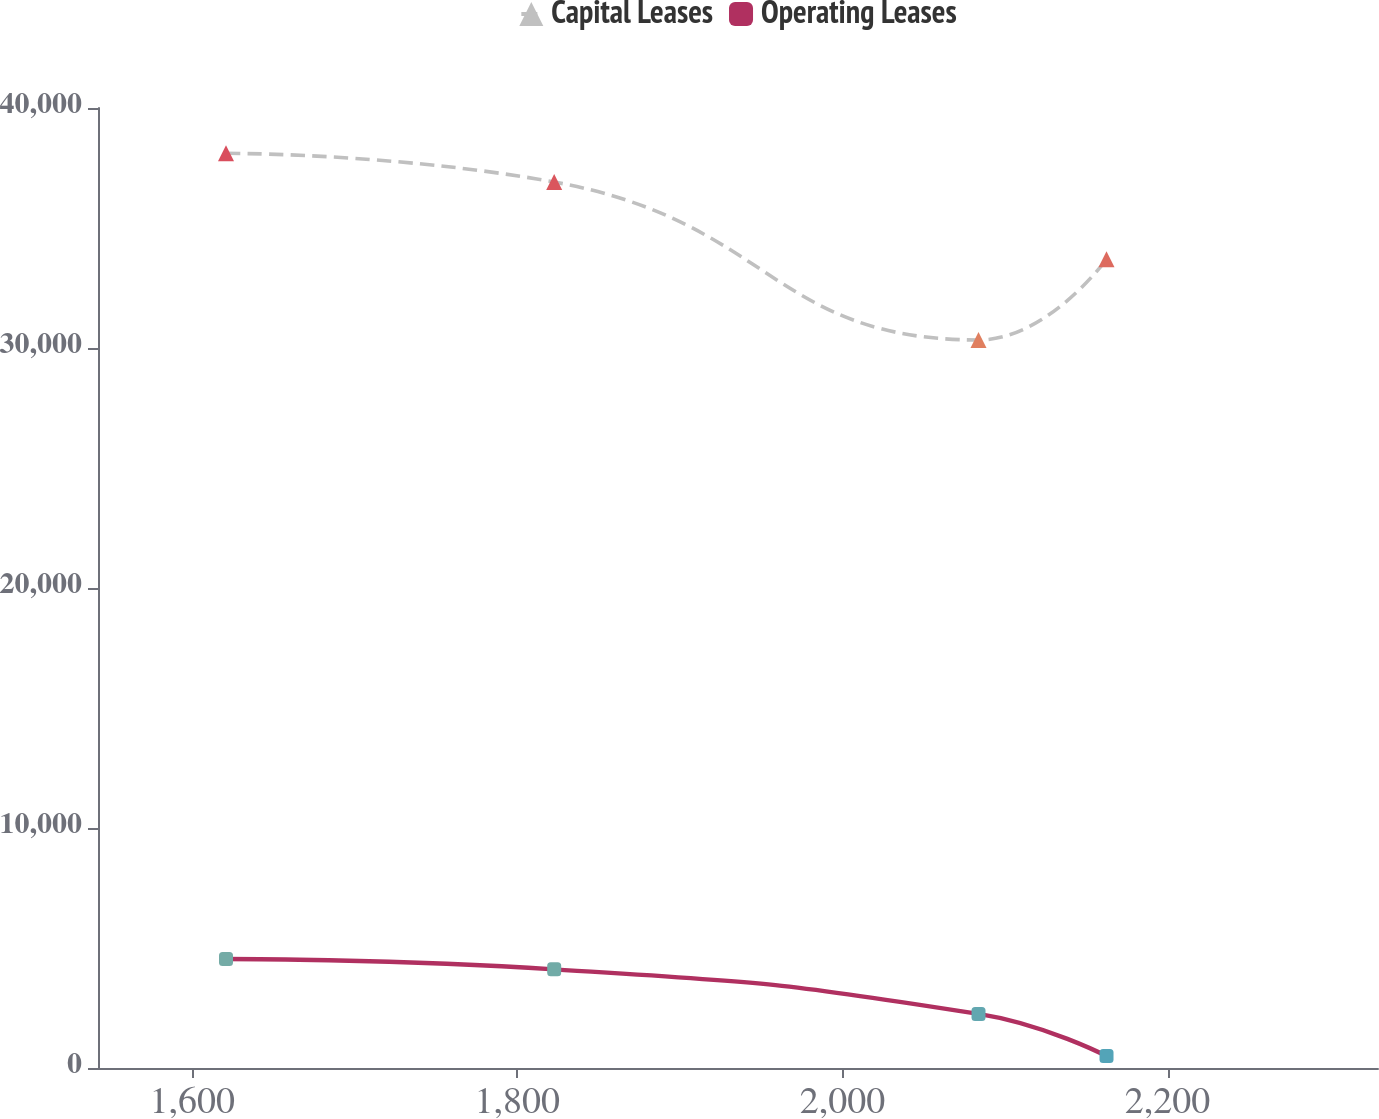Convert chart to OTSL. <chart><loc_0><loc_0><loc_500><loc_500><line_chart><ecel><fcel>Capital Leases<fcel>Operating Leases<nl><fcel>1620.78<fcel>38112.4<fcel>4541.73<nl><fcel>1822.68<fcel>36916.1<fcel>4110.55<nl><fcel>2083.72<fcel>30334.4<fcel>2254.12<nl><fcel>2162.46<fcel>33698.1<fcel>495.02<nl><fcel>2408.22<fcel>26011.9<fcel>63.84<nl></chart> 